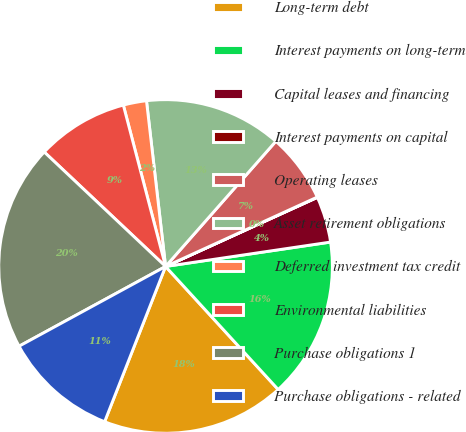Convert chart to OTSL. <chart><loc_0><loc_0><loc_500><loc_500><pie_chart><fcel>Long-term debt<fcel>Interest payments on long-term<fcel>Capital leases and financing<fcel>Interest payments on capital<fcel>Operating leases<fcel>Asset retirement obligations<fcel>Deferred investment tax credit<fcel>Environmental liabilities<fcel>Purchase obligations 1<fcel>Purchase obligations - related<nl><fcel>17.75%<fcel>15.54%<fcel>4.46%<fcel>0.03%<fcel>6.68%<fcel>13.32%<fcel>2.25%<fcel>8.89%<fcel>19.97%<fcel>11.11%<nl></chart> 